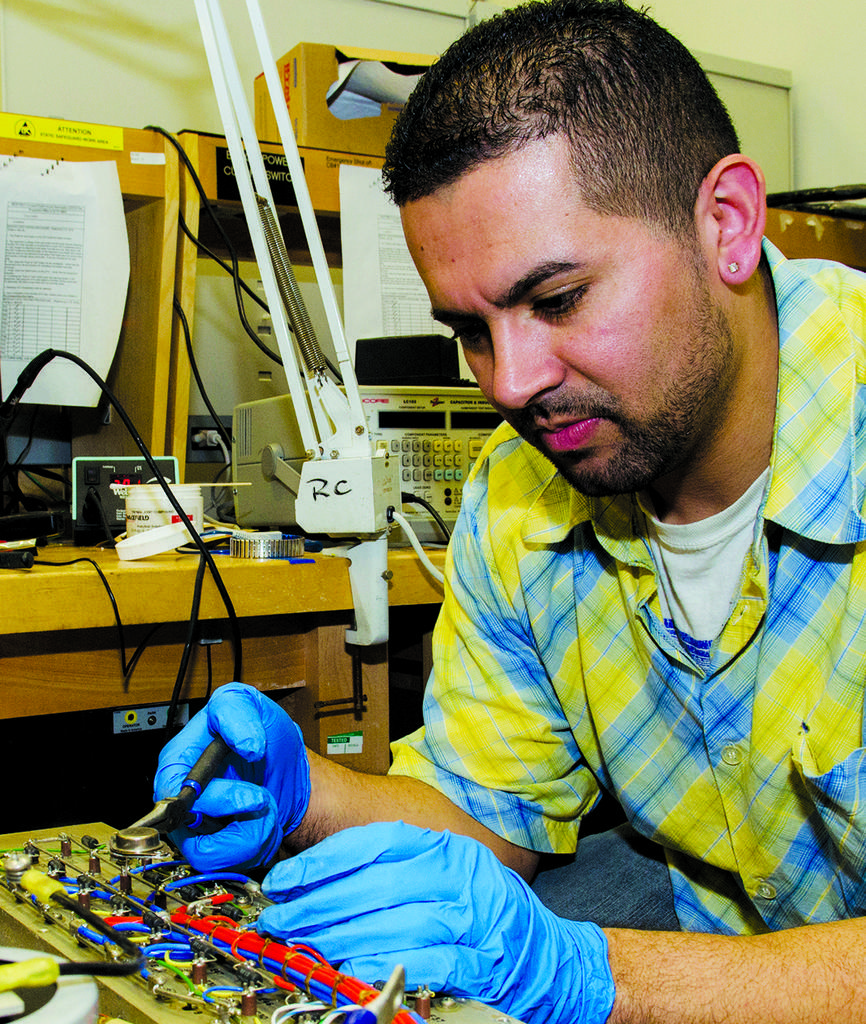In one or two sentences, can you explain what this image depicts? This picture is taken inside the room. In this image, on the right side, we can see a person wearing gloves to his hands and holding some object in his hand and the person is in front of the electronic equipment. In the background, we can see a table, on the table, we can see some electronic equipment, electronic instruments, electrical wires, pole, paper with some text written on it. In the background, we can also see a door. 